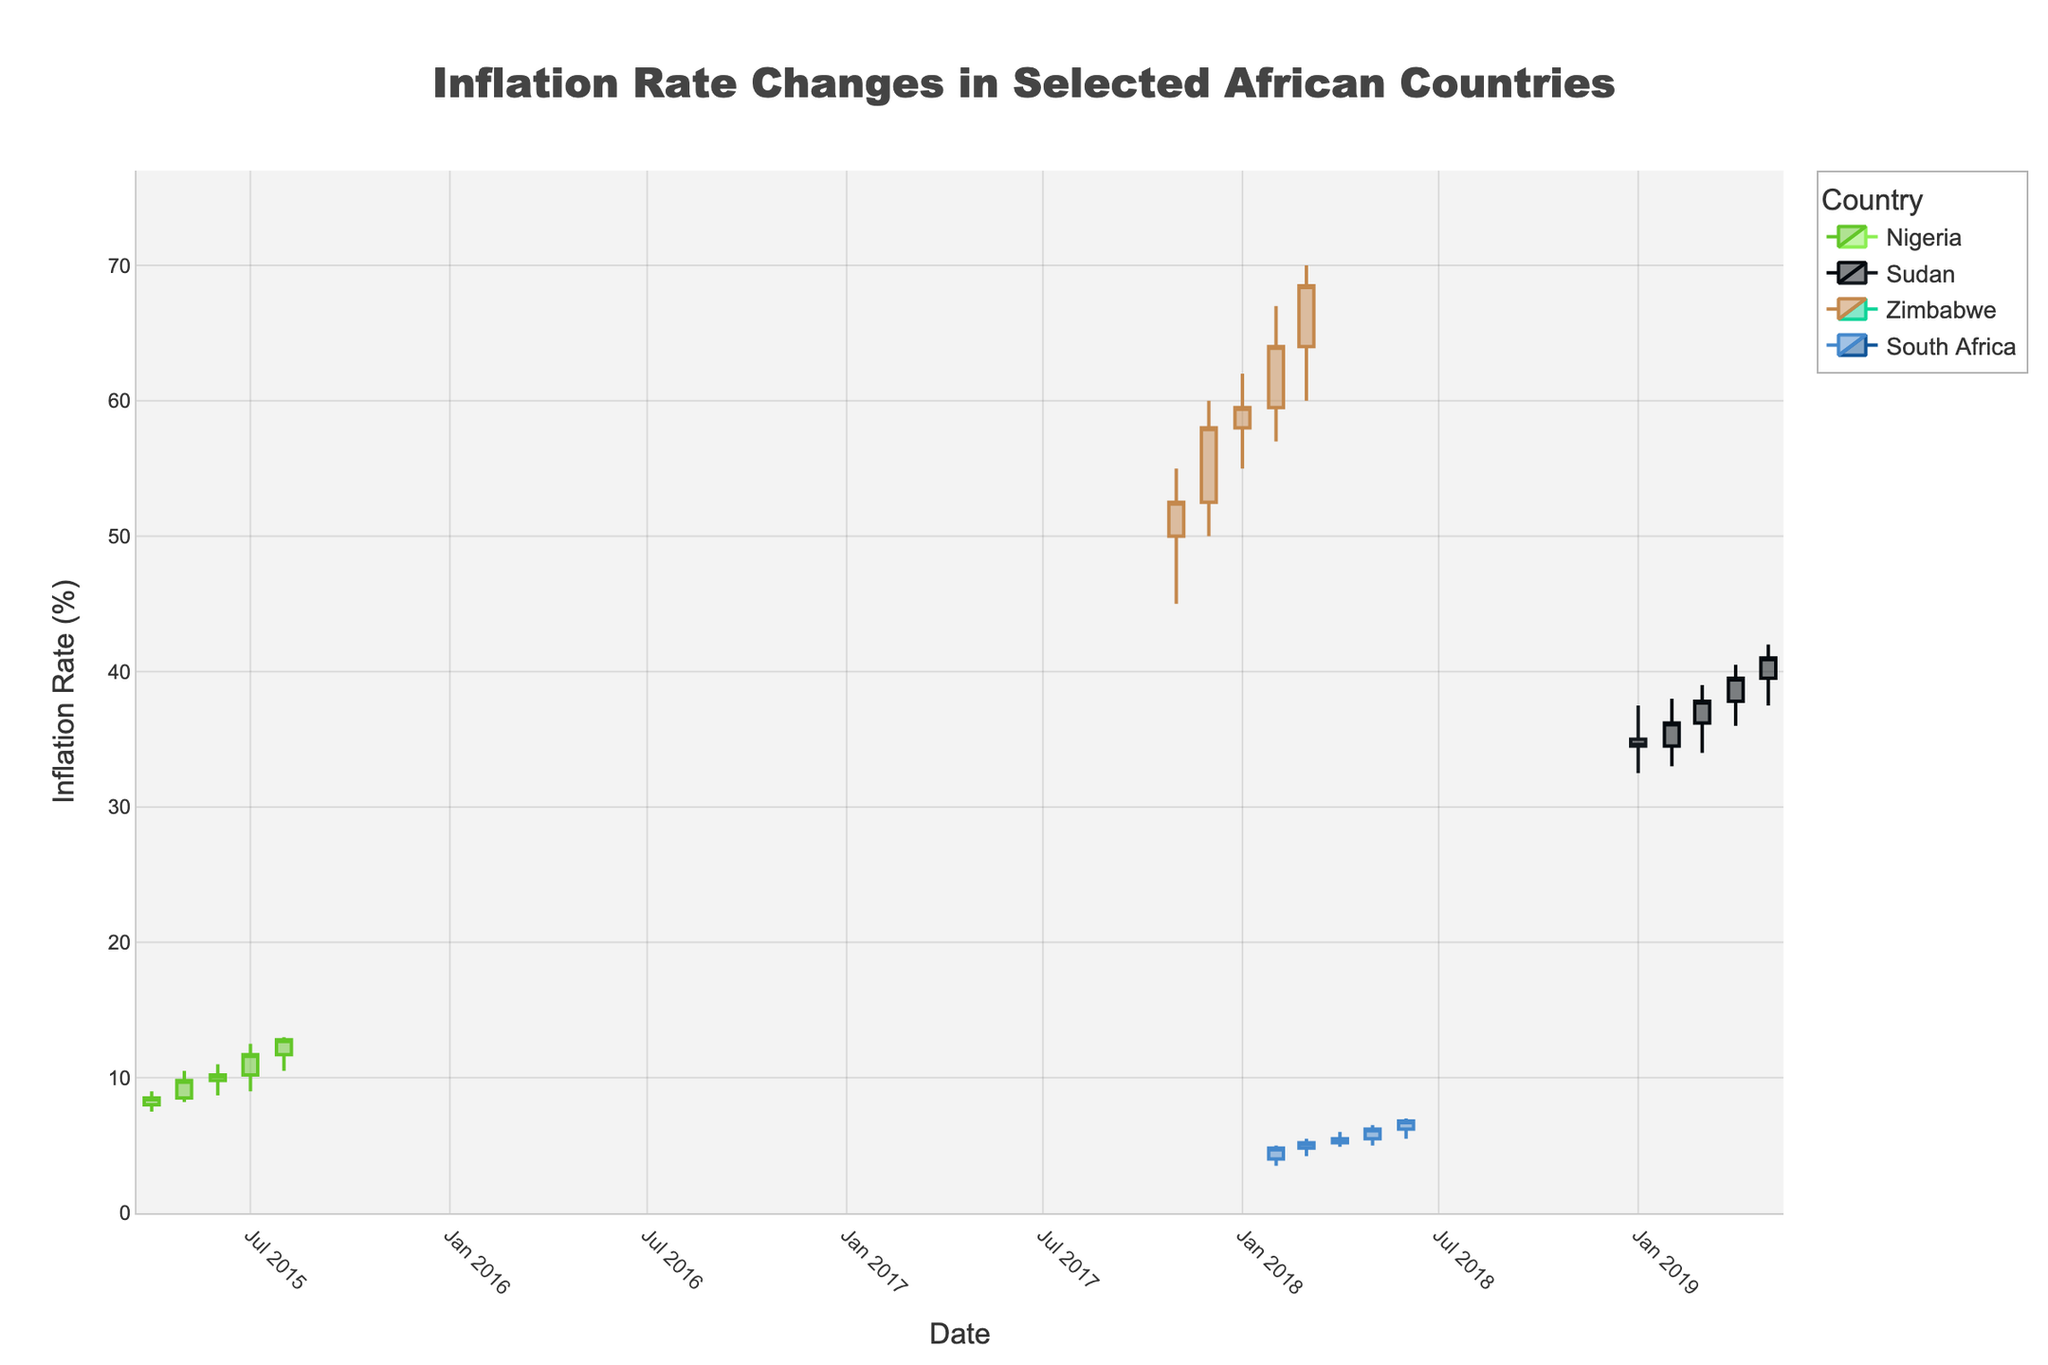what is the title of the plot? The title is a descriptive element generally found at the top of the plot which gives an overview of what the plot represents. In this case, it describes that the plot is about inflation rate changes in selected African countries.
Answer: Inflation Rate Changes in Selected African Countries what color variations represent increasing and decreasing in the plot? In candlestick plots, colors typically represent increasing or decreasing values. Increasing values are usually shown in a positive color (e.g., green), and decreasing values in a negative color (e.g., red). Observing the plot, one can note the distinct colors for each country and the increasing/decreasing trends.
Answer: Increasing and decreasing colors vary by country how many data points does each country have? This involves counting the data points plotted for each country. In the case of Nigeria, there are 5 data points (from April 2015 to August 2015). The same step is repeated for other countries listed (Sudan, Zimbabwe, and South Africa).
Answer: Each country has 5 data points what is the inflation rate range for Zimbabwe in the given period? Candlestick plots show high and low values for each period. For Zimbabwe, we observe the highest value (70% in March 2018) and the lowest value (45% in November 2017). The range can be determined by subtracting the lowest from the highest value.
Answer: The range is 25% how did Nigeria's inflation rate trend from April 2015 to August 2015? To identify the trend, observe the open and close values per period. Starting at 8.0% (open) in April 2015 and closing at 12.8% in August 2015, Nigeria's inflation rate shows a general upward trend over this period.
Answer: Upward trend which country experienced the highest peak inflation rate among the listed countries? By examining the high values across all given periods for each country, we identify Zimbabwe with the highest inflation rate reaching 70% in March 2018.
Answer: Zimbabwe compare the inflation rate changes between February and March 2018 for South Africa. For February 2018, the close value is 4.8%, and for March 2018, the close value is 5.2%. By comparing these values, we can see that the inflation rate increased by 0.4%.
Answer: Increased by 0.4% what was the inflation rate trend in Sudan from January 2019 to May 2019? Analyzing the open and close values across the given months for Sudan shows the general direction of the trend. Starting at 35.0% (open) in January and closing at 41.0% in May 2019 indicates an upward trend.
Answer: Upward trend which month did Zimbabwe's inflation rate close its highest, and what was the value? Observing the "close" values for each month, December 2017 shows the highest closing value at 58.0%.
Answer: December 2017 with a value of 58.0% 